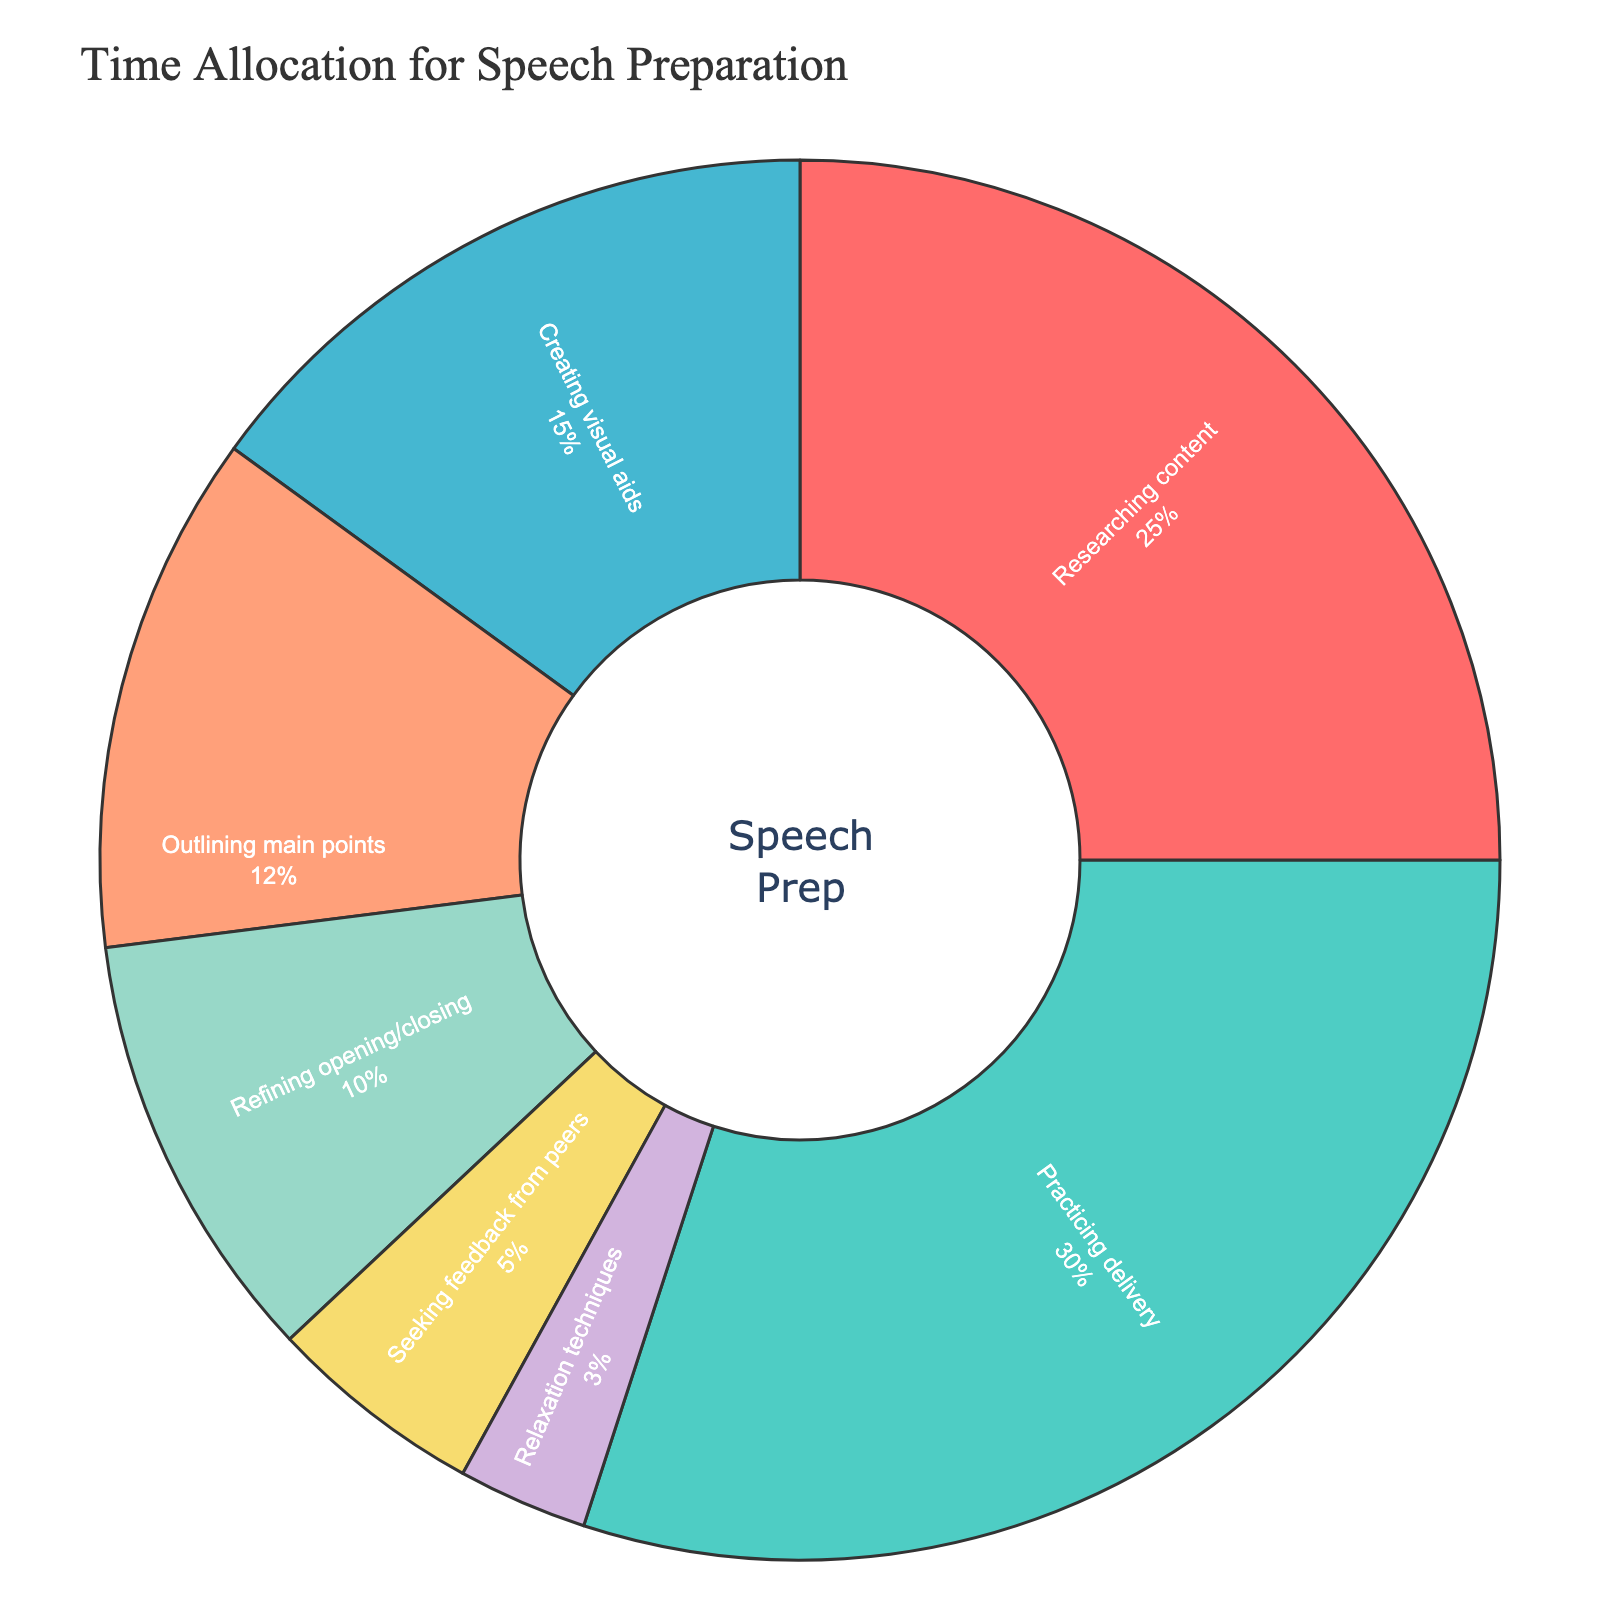What's the largest time allocation for speech preparation? The figure shows various time allocations with percentage values. The largest segment can be identified by looking at the percentage values. Researching content has 25%, Practicing delivery has 30%, Creating visual aids has 15%, Outlining main points has 12%, Refining opening/closing has 10%, Seeking feedback from peers has 5%, and Relaxation techniques have 3%. The largest percentage is 30%.
Answer: Practicing delivery What is the smallest time allocation activity? The figure shows the time allocations with percentage values. The smallest segment can be identified by looking at the percentage values and finding the smallest one. Relaxation techniques have the smallest percentage at 3%.
Answer: Relaxation techniques How much more time is allocated to Practicing Delivery than to Seeking feedback from peers? Practicing Delivery is allocated 30%, and Seeking feedback from peers is allocated 5%. The difference in allocation is calculated by subtracting the smaller percentage from the larger percentage: 30% - 5% = 25%.
Answer: 25% What is the combined time allocation for Creating visual aids and Outlining main points? The figure shows Creating visual aids with 15% and Outlining main points with 12%. The combined time allocation is the sum of these percentages: 15% + 12% = 27%.
Answer: 27% Which aspects have time allocations greater than 10%? The figure shows several time allocations: Researching content (25%), Practicing delivery (30%), Creating visual aids (15%), Outlining main points (12%), Refining opening/closing (10%), Seeking feedback from peers (5%), and Relaxation techniques (3%). Aspects greater than 10% are Researching content, Practicing delivery, Creating visual aids, and Outlining main points.
Answer: Researching content, Practicing delivery, Creating visual aids, Outlining main points How is the total time allocation divided among tasks with less than 10% each? The figure shows the time allocations: Refining opening/closing (10%), Seeking feedback from peers (5%), and Relaxation techniques (3%). The combined allocation is 10% + 5% + 3% = 18%.
Answer: 18% Which segment is colored green in the pie chart? The color green corresponds to a specific percentage segment in the pie chart. Practicing delivery, which has a percentage of 30%, is represented by the green color.
Answer: Practicing delivery What is the difference between the time allocated for Researching content and that for Refining opening/closing? Researching content has 25%, and Refining opening/closing has 10%. The difference is calculated by subtracting the smaller percentage from the larger percentage: 25% - 10% = 15%.
Answer: 15% If you combine Researching content and Seeking feedback from peers, does their total exceed the percentage allocated to Practicing delivery? Researching content is allocated 25%, and Seeking feedback from peers is allocated 5%. The total is 25% + 5% = 30%. Practicing delivery is also 30%. So, their total equals the percentage allocated to Practicing delivery.
Answer: No, it equals How many activities have time allocations less than or equal to 5%? The figure provides various percentages for activities. Out of these, Seeking feedback from peers has 5%, and Relaxation techniques have 3%. There are 2 activities with allocations less than or equal to 5%.
Answer: 2 